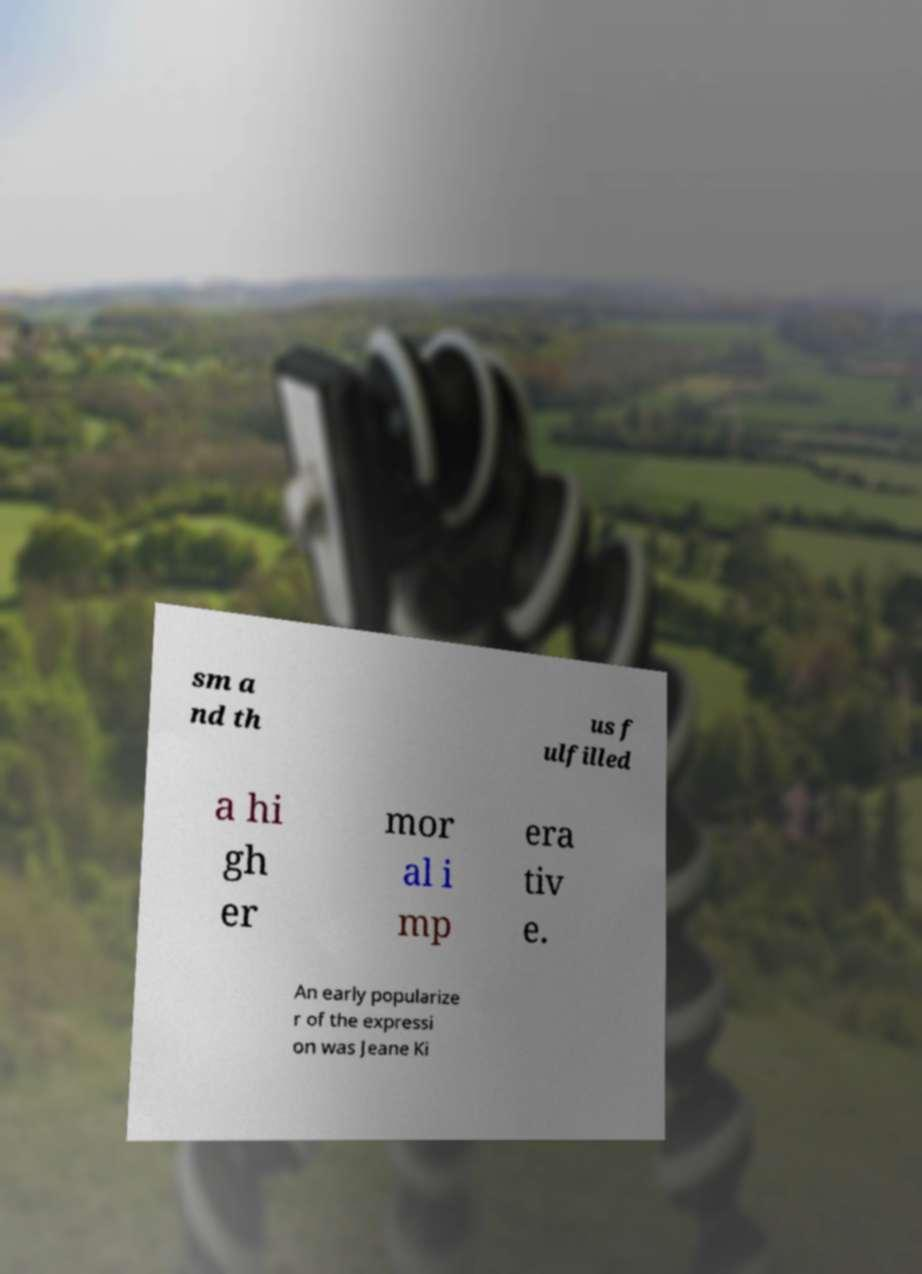Could you extract and type out the text from this image? sm a nd th us f ulfilled a hi gh er mor al i mp era tiv e. An early popularize r of the expressi on was Jeane Ki 